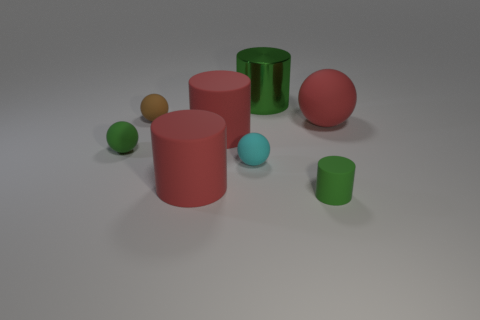The cyan object that is the same material as the green sphere is what shape?
Provide a succinct answer. Sphere. What number of red objects are large rubber cylinders or tiny things?
Your answer should be very brief. 2. Are there any small cyan balls on the left side of the large rubber cylinder that is behind the big red matte object that is in front of the cyan object?
Offer a terse response. No. Are there fewer large rubber cylinders than small gray metallic cylinders?
Your response must be concise. No. Is the shape of the small green object that is behind the cyan thing the same as  the small brown thing?
Your answer should be compact. Yes. Is there a small rubber cylinder?
Your answer should be compact. Yes. There is a small matte sphere that is behind the large object right of the small rubber thing on the right side of the small cyan matte object; what is its color?
Offer a very short reply. Brown. Are there an equal number of small matte spheres that are behind the brown ball and large matte objects that are left of the large green metal thing?
Your answer should be compact. No. What shape is the cyan matte object that is the same size as the green rubber cylinder?
Ensure brevity in your answer.  Sphere. Are there any rubber objects of the same color as the large ball?
Your response must be concise. Yes. 